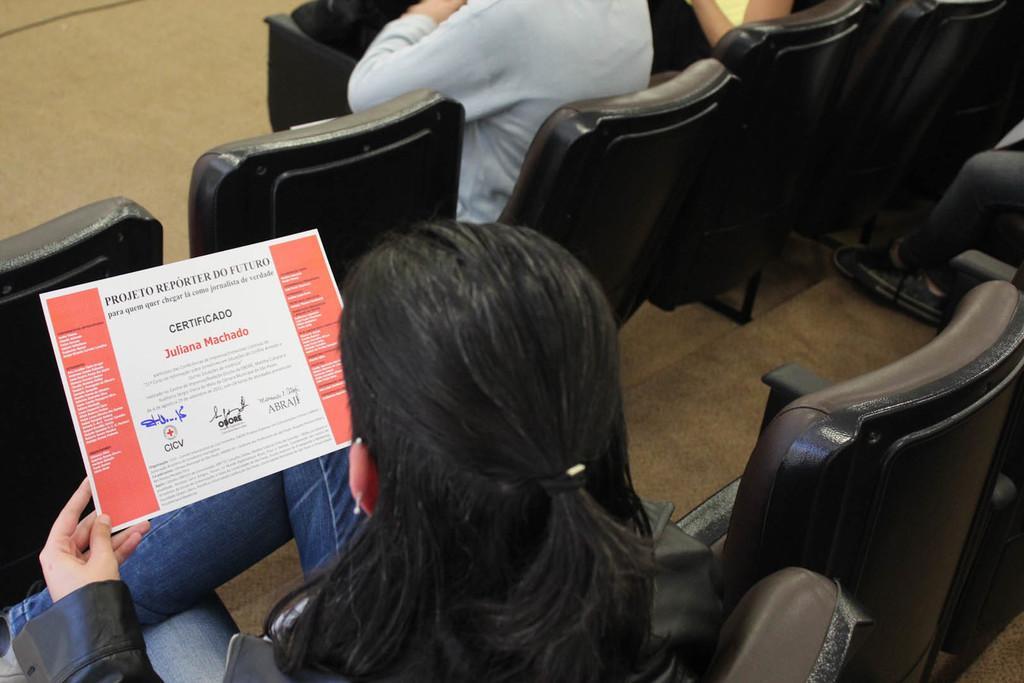Describe this image in one or two sentences. There is a woman sitting on a chair and she is looking at this paper. In front there is a person sitting on a chair. 